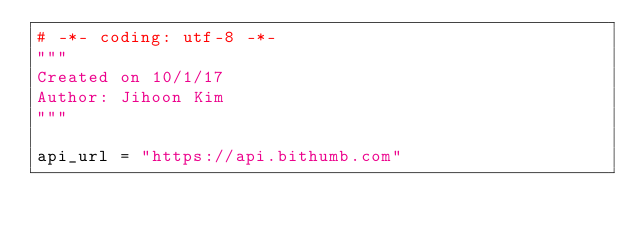<code> <loc_0><loc_0><loc_500><loc_500><_Python_># -*- coding: utf-8 -*-
"""
Created on 10/1/17
Author: Jihoon Kim
"""

api_url = "https://api.bithumb.com"
</code> 